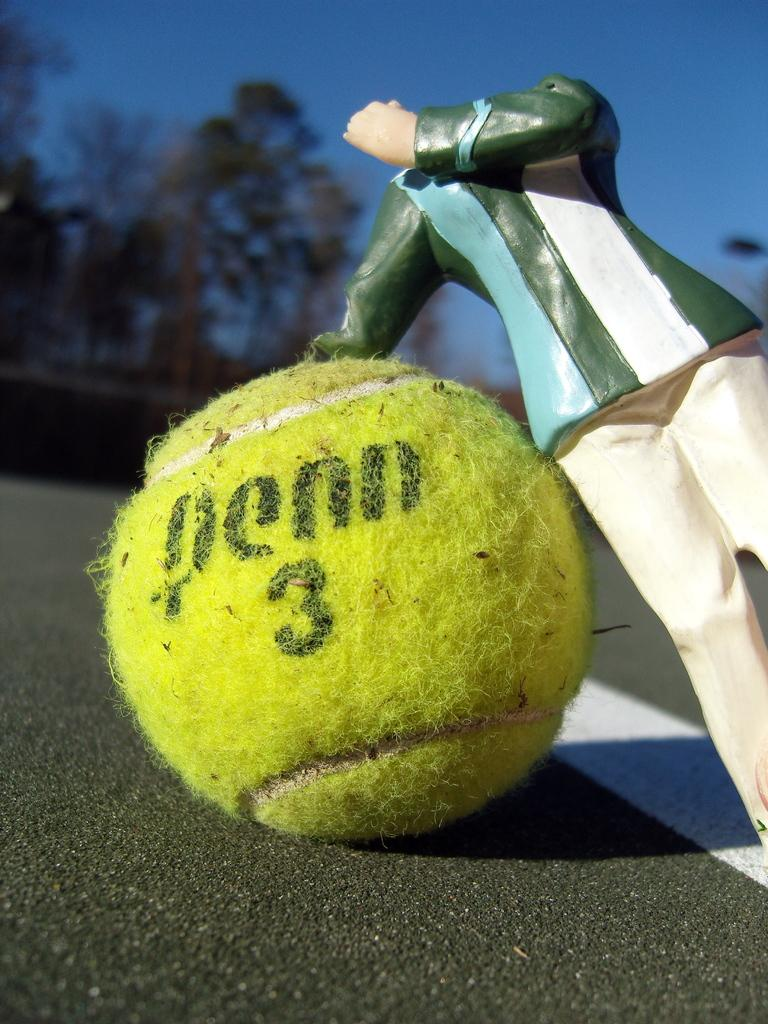<image>
Provide a brief description of the given image. A figurine with no head is propped up by a tennis ball that says penn 3. 